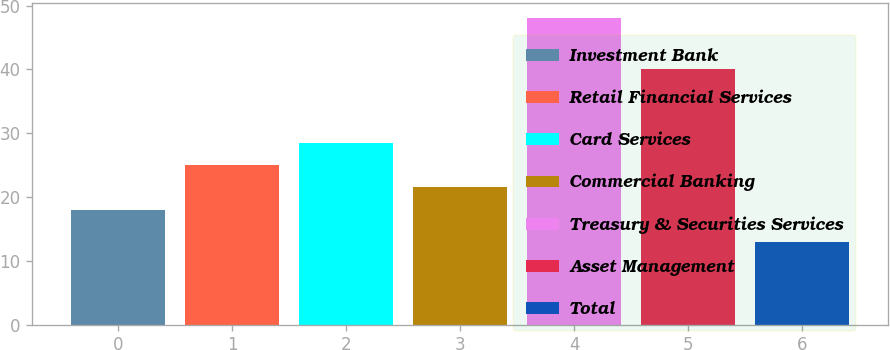<chart> <loc_0><loc_0><loc_500><loc_500><bar_chart><fcel>Investment Bank<fcel>Retail Financial Services<fcel>Card Services<fcel>Commercial Banking<fcel>Treasury & Securities Services<fcel>Asset Management<fcel>Total<nl><fcel>18<fcel>25<fcel>28.5<fcel>21.5<fcel>48<fcel>40<fcel>13<nl></chart> 